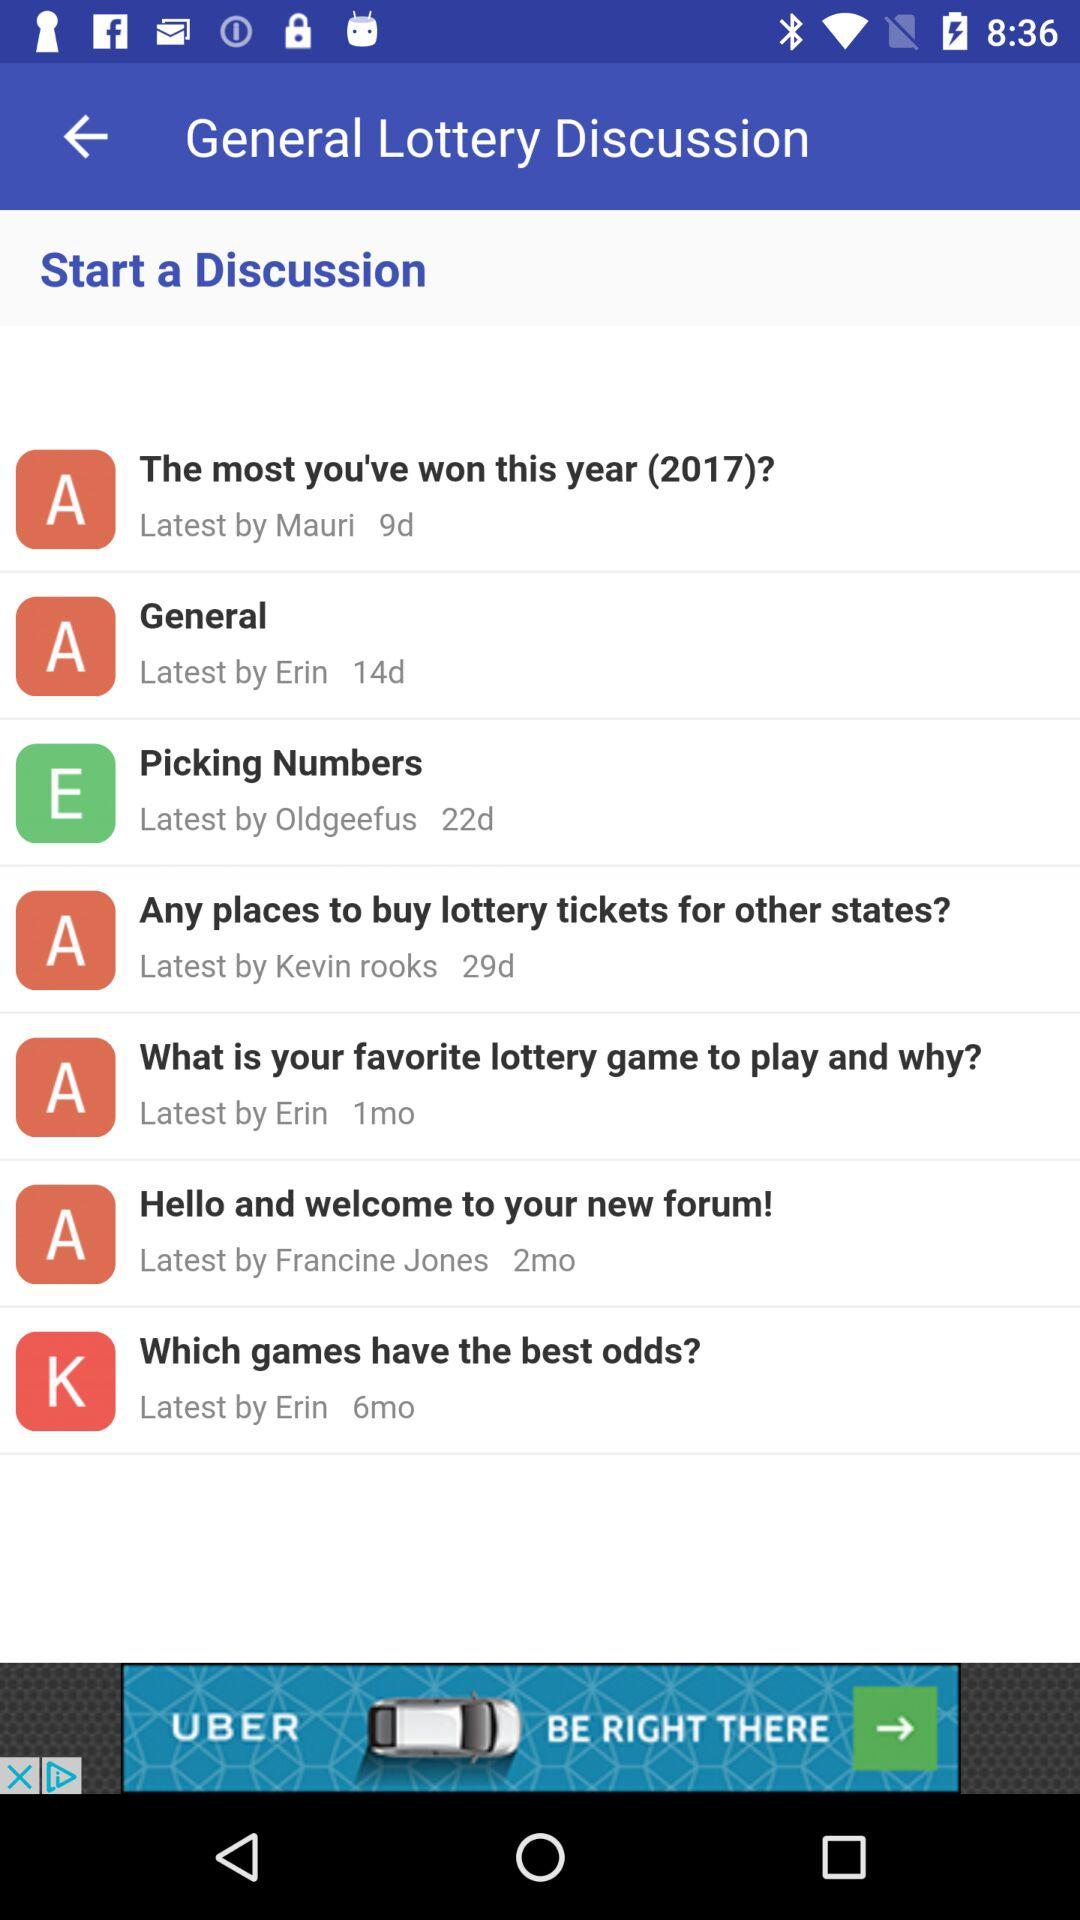How many months ago did we start the discussion about "Which games have the best odds?"? You started the discussion 6 months ago. 